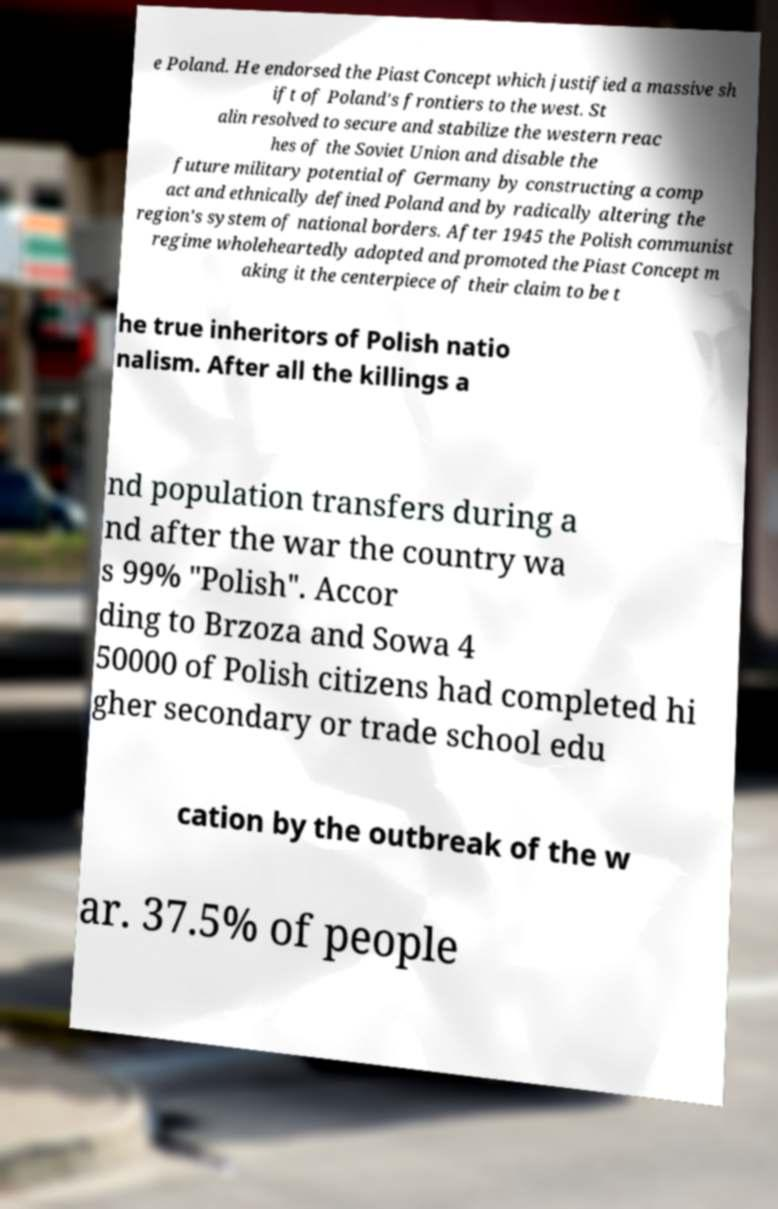What messages or text are displayed in this image? I need them in a readable, typed format. e Poland. He endorsed the Piast Concept which justified a massive sh ift of Poland's frontiers to the west. St alin resolved to secure and stabilize the western reac hes of the Soviet Union and disable the future military potential of Germany by constructing a comp act and ethnically defined Poland and by radically altering the region's system of national borders. After 1945 the Polish communist regime wholeheartedly adopted and promoted the Piast Concept m aking it the centerpiece of their claim to be t he true inheritors of Polish natio nalism. After all the killings a nd population transfers during a nd after the war the country wa s 99% "Polish". Accor ding to Brzoza and Sowa 4 50000 of Polish citizens had completed hi gher secondary or trade school edu cation by the outbreak of the w ar. 37.5% of people 